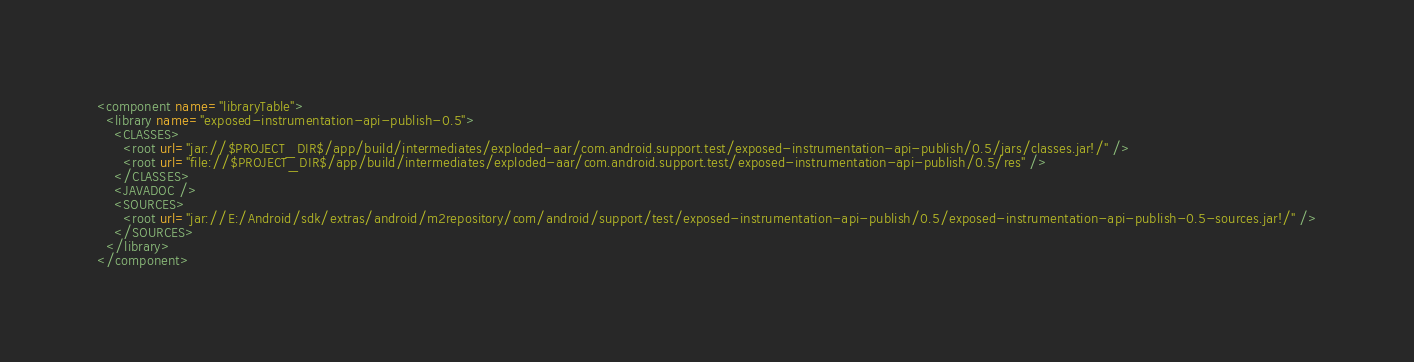<code> <loc_0><loc_0><loc_500><loc_500><_XML_><component name="libraryTable">
  <library name="exposed-instrumentation-api-publish-0.5">
    <CLASSES>
      <root url="jar://$PROJECT_DIR$/app/build/intermediates/exploded-aar/com.android.support.test/exposed-instrumentation-api-publish/0.5/jars/classes.jar!/" />
      <root url="file://$PROJECT_DIR$/app/build/intermediates/exploded-aar/com.android.support.test/exposed-instrumentation-api-publish/0.5/res" />
    </CLASSES>
    <JAVADOC />
    <SOURCES>
      <root url="jar://E:/Android/sdk/extras/android/m2repository/com/android/support/test/exposed-instrumentation-api-publish/0.5/exposed-instrumentation-api-publish-0.5-sources.jar!/" />
    </SOURCES>
  </library>
</component></code> 